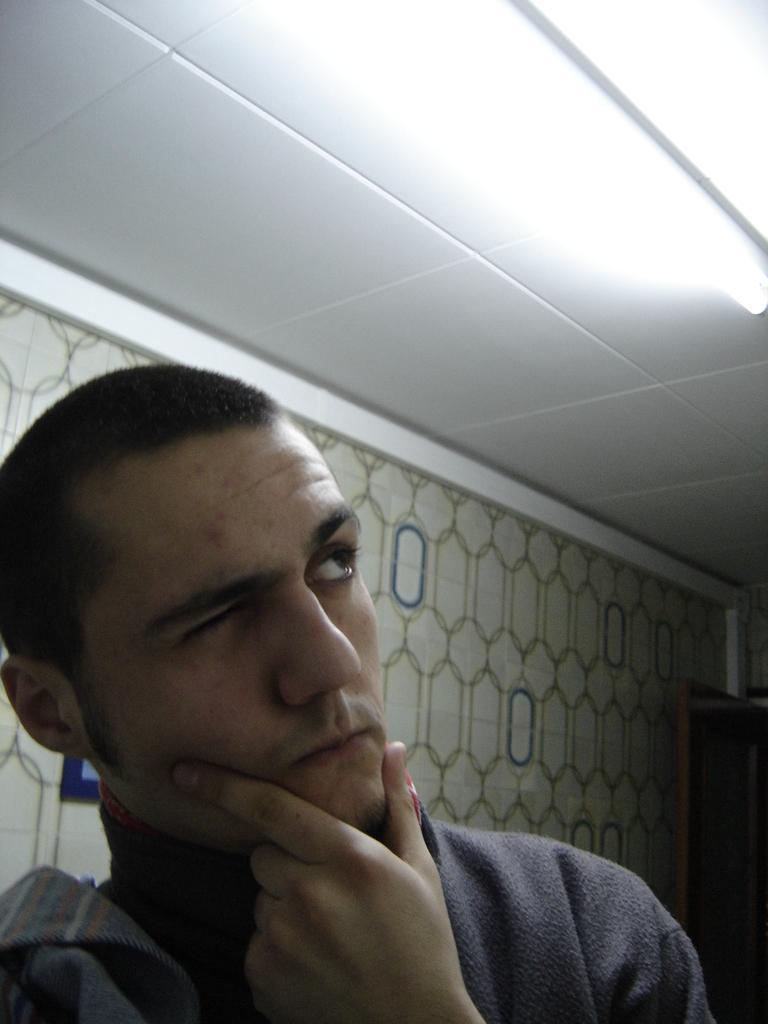In one or two sentences, can you explain what this image depicts? In the picture we can see a man standing and keeping his hand on the chin and thinking something and closing one eye and in the background, we can see a wall with some designs on it and to the ceiling we can see the light. 